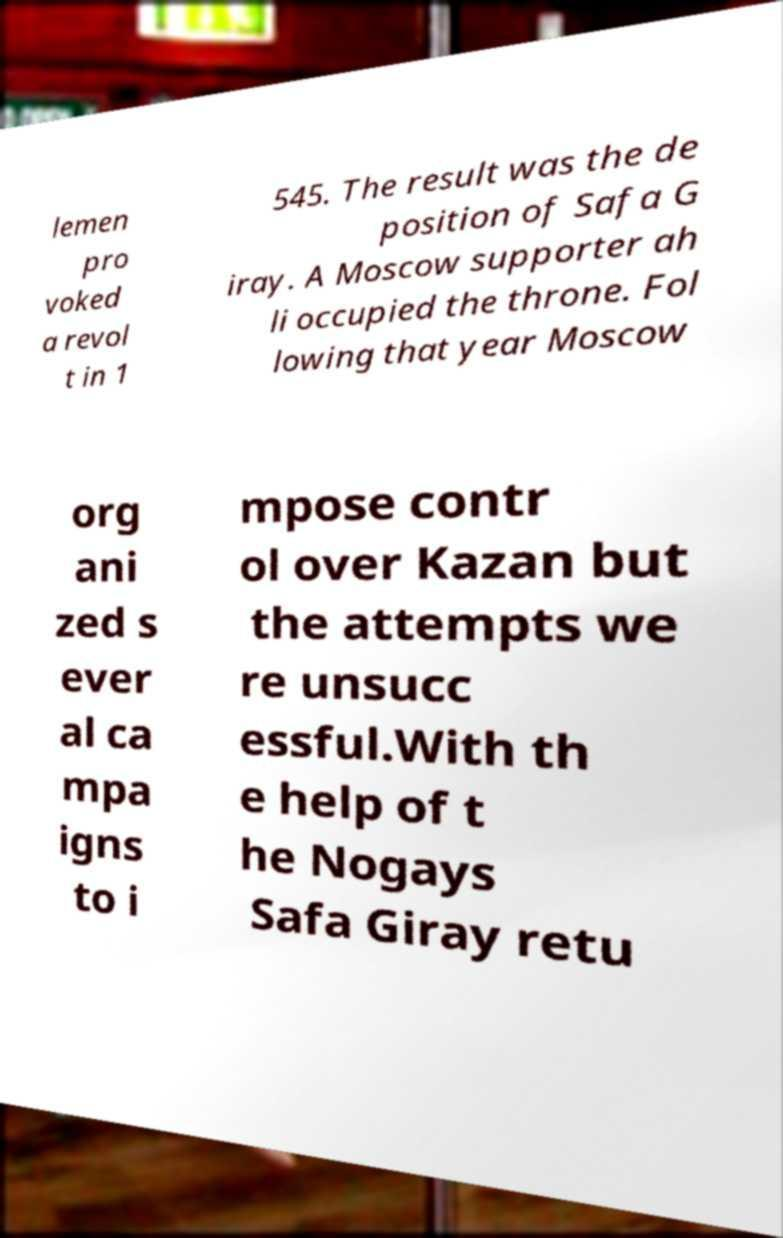Can you read and provide the text displayed in the image?This photo seems to have some interesting text. Can you extract and type it out for me? lemen pro voked a revol t in 1 545. The result was the de position of Safa G iray. A Moscow supporter ah li occupied the throne. Fol lowing that year Moscow org ani zed s ever al ca mpa igns to i mpose contr ol over Kazan but the attempts we re unsucc essful.With th e help of t he Nogays Safa Giray retu 